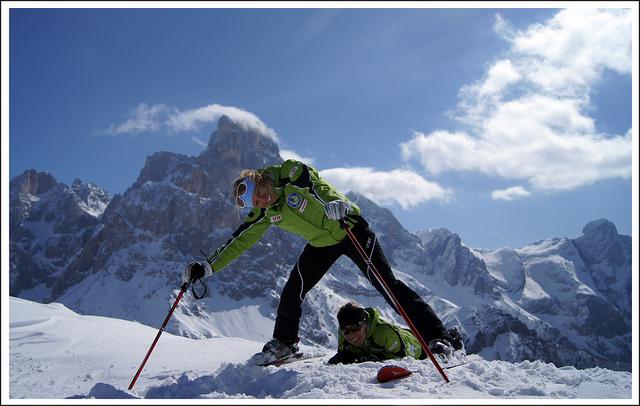Is the glare potentially dangerous, here?
Concise answer only. Yes. Are they at the peak?
Concise answer only. Yes. Is she leaning to the left or right?
Keep it brief. Left. Is the weather cold here?
Give a very brief answer. Yes. What color are the people's jackets?
Be succinct. Green. 